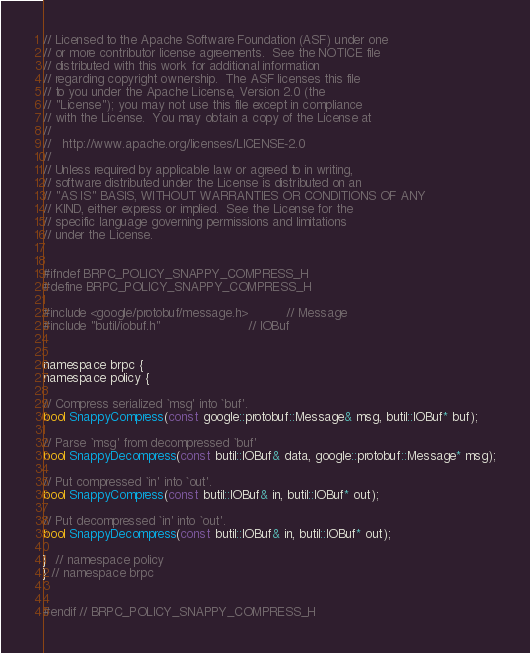Convert code to text. <code><loc_0><loc_0><loc_500><loc_500><_C_>// Licensed to the Apache Software Foundation (ASF) under one
// or more contributor license agreements.  See the NOTICE file
// distributed with this work for additional information
// regarding copyright ownership.  The ASF licenses this file
// to you under the Apache License, Version 2.0 (the
// "License"); you may not use this file except in compliance
// with the License.  You may obtain a copy of the License at
//
//   http://www.apache.org/licenses/LICENSE-2.0
//
// Unless required by applicable law or agreed to in writing,
// software distributed under the License is distributed on an
// "AS IS" BASIS, WITHOUT WARRANTIES OR CONDITIONS OF ANY
// KIND, either express or implied.  See the License for the
// specific language governing permissions and limitations
// under the License.


#ifndef BRPC_POLICY_SNAPPY_COMPRESS_H
#define BRPC_POLICY_SNAPPY_COMPRESS_H

#include <google/protobuf/message.h>          // Message
#include "butil/iobuf.h"                       // IOBuf


namespace brpc {
namespace policy {

// Compress serialized `msg' into `buf'.
bool SnappyCompress(const google::protobuf::Message& msg, butil::IOBuf* buf);

// Parse `msg' from decompressed `buf'
bool SnappyDecompress(const butil::IOBuf& data, google::protobuf::Message* msg);

// Put compressed `in' into `out'.
bool SnappyCompress(const butil::IOBuf& in, butil::IOBuf* out);

// Put decompressed `in' into `out'.
bool SnappyDecompress(const butil::IOBuf& in, butil::IOBuf* out);

}  // namespace policy
} // namespace brpc


#endif // BRPC_POLICY_SNAPPY_COMPRESS_H
</code> 